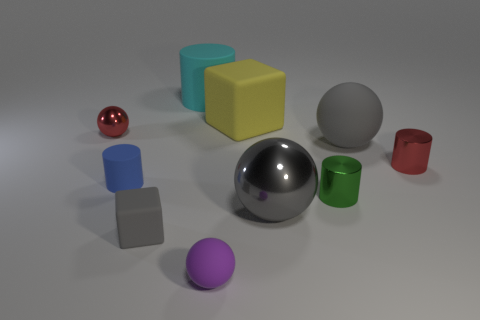There is another ball that is the same color as the big rubber sphere; what material is it?
Offer a very short reply. Metal. There is another large thing that is the same shape as the blue thing; what is its material?
Provide a short and direct response. Rubber. What color is the sphere that is both on the right side of the purple rubber ball and in front of the large gray matte thing?
Make the answer very short. Gray. What number of other objects are there of the same material as the tiny gray cube?
Offer a terse response. 5. Is the number of small gray rubber things less than the number of large rubber objects?
Make the answer very short. Yes. Are the large yellow object and the cylinder behind the large yellow object made of the same material?
Your response must be concise. Yes. There is a small rubber object that is behind the large metal ball; what shape is it?
Give a very brief answer. Cylinder. Is there anything else that is the same color as the tiny metallic sphere?
Offer a terse response. Yes. Are there fewer red metal objects to the right of the tiny blue rubber cylinder than rubber cylinders?
Ensure brevity in your answer.  Yes. How many blue objects are the same size as the blue cylinder?
Offer a terse response. 0. 